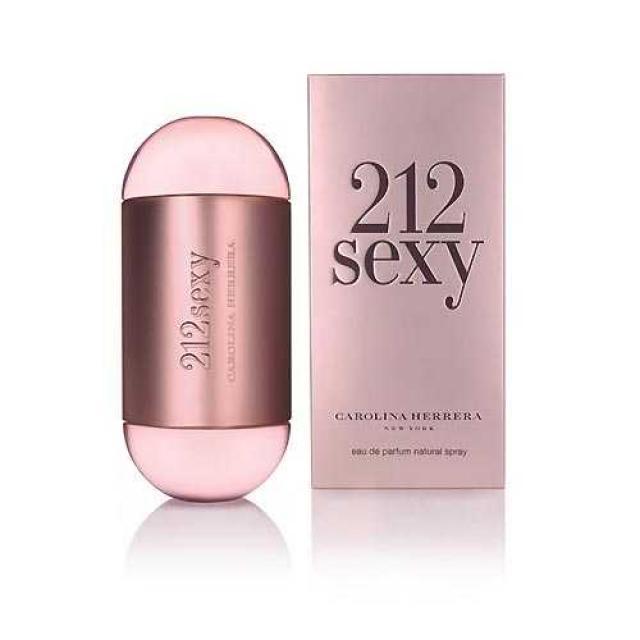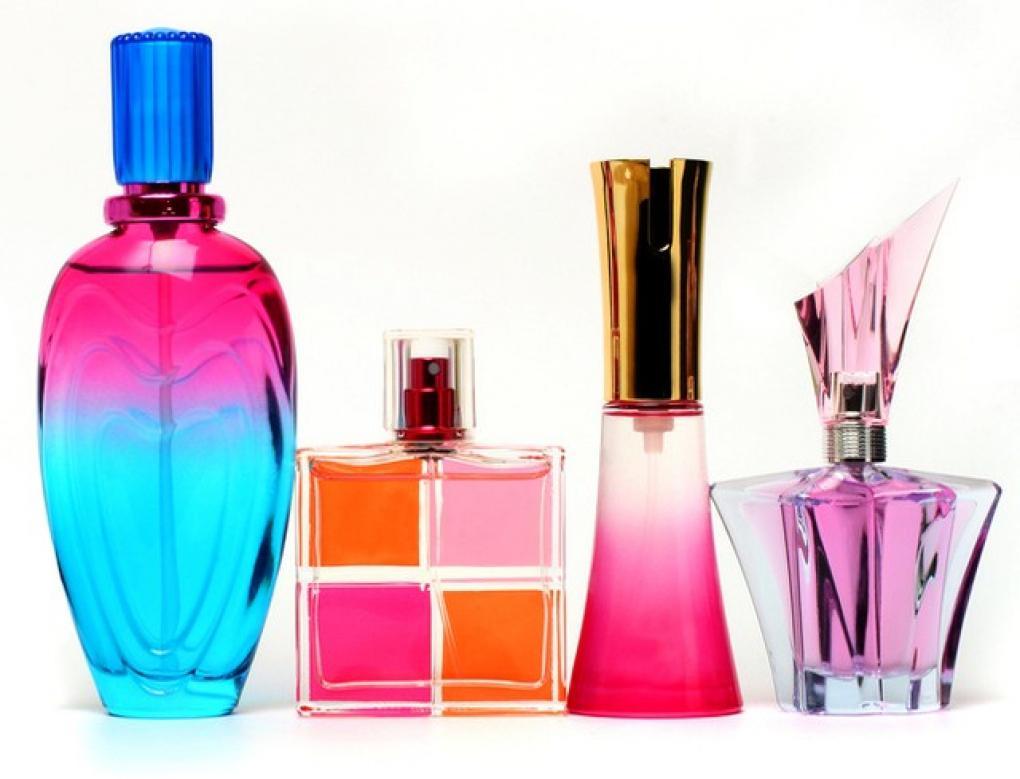The first image is the image on the left, the second image is the image on the right. Evaluate the accuracy of this statement regarding the images: "There is a bottle shaped like an animal.". Is it true? Answer yes or no. No. The first image is the image on the left, the second image is the image on the right. Considering the images on both sides, is "There is a single vial near its box in one of the images." valid? Answer yes or no. Yes. The first image is the image on the left, the second image is the image on the right. Evaluate the accuracy of this statement regarding the images: "One image includes a fragrance bottle with a shape inspired by some type of animal.". Is it true? Answer yes or no. No. The first image is the image on the left, the second image is the image on the right. Assess this claim about the two images: "The left image contains only two fragrance-related objects, which are side-by-side but not touching and include a lavender bottle with a metallic element.". Correct or not? Answer yes or no. Yes. 